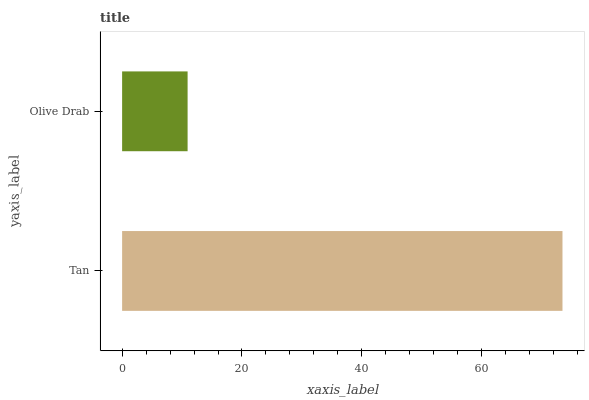Is Olive Drab the minimum?
Answer yes or no. Yes. Is Tan the maximum?
Answer yes or no. Yes. Is Olive Drab the maximum?
Answer yes or no. No. Is Tan greater than Olive Drab?
Answer yes or no. Yes. Is Olive Drab less than Tan?
Answer yes or no. Yes. Is Olive Drab greater than Tan?
Answer yes or no. No. Is Tan less than Olive Drab?
Answer yes or no. No. Is Tan the high median?
Answer yes or no. Yes. Is Olive Drab the low median?
Answer yes or no. Yes. Is Olive Drab the high median?
Answer yes or no. No. Is Tan the low median?
Answer yes or no. No. 